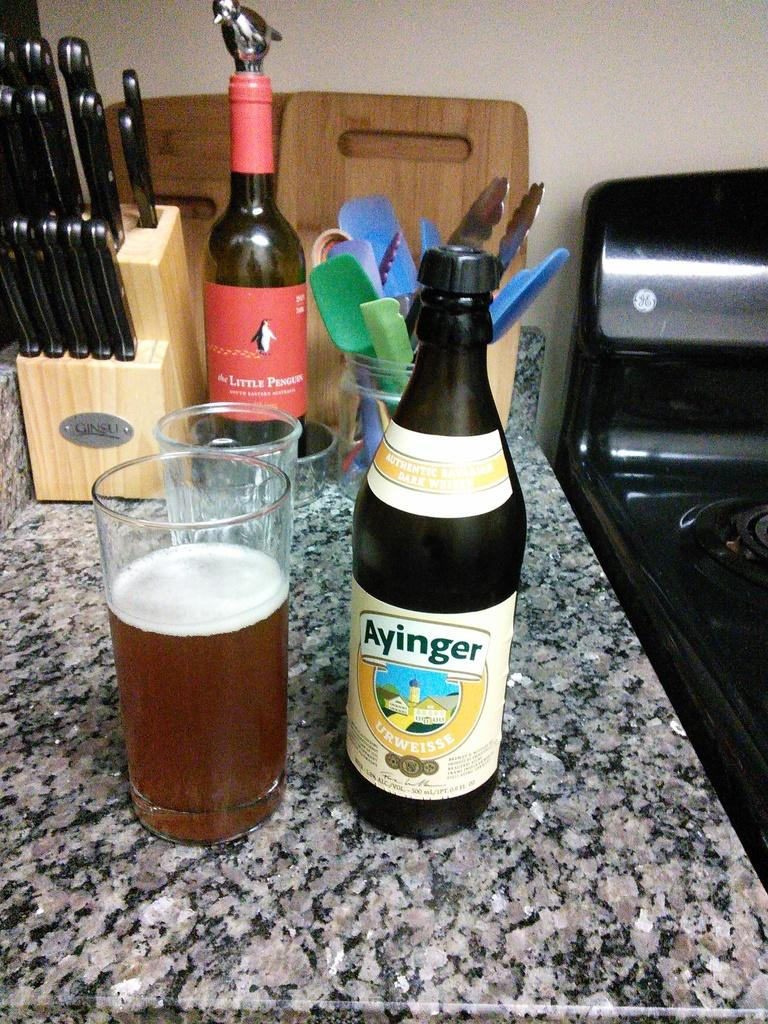<image>
Share a concise interpretation of the image provided. A bottle of Ayinger is next to a full glass. 